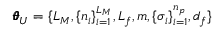<formula> <loc_0><loc_0><loc_500><loc_500>\pm b { \theta } _ { U } = \{ L _ { M } , \{ n _ { i } \} _ { i = 1 } ^ { L _ { M } } , L _ { f } , m , \{ \sigma _ { i } \} _ { i = 1 } ^ { n _ { p } } , d _ { f } \}</formula> 